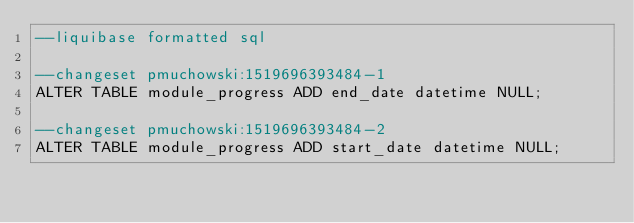Convert code to text. <code><loc_0><loc_0><loc_500><loc_500><_SQL_>--liquibase formatted sql

--changeset pmuchowski:1519696393484-1
ALTER TABLE module_progress ADD end_date datetime NULL;

--changeset pmuchowski:1519696393484-2
ALTER TABLE module_progress ADD start_date datetime NULL;

</code> 